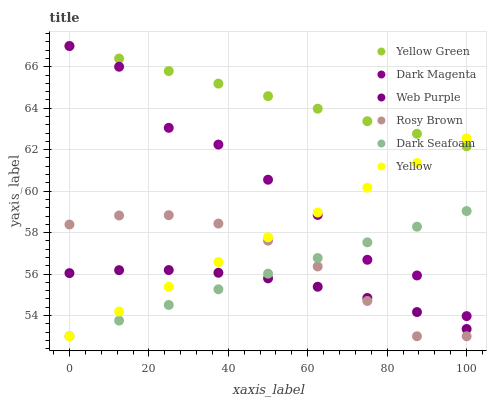Does Web Purple have the minimum area under the curve?
Answer yes or no. Yes. Does Yellow Green have the maximum area under the curve?
Answer yes or no. Yes. Does Rosy Brown have the minimum area under the curve?
Answer yes or no. No. Does Rosy Brown have the maximum area under the curve?
Answer yes or no. No. Is Dark Seafoam the smoothest?
Answer yes or no. Yes. Is Dark Magenta the roughest?
Answer yes or no. Yes. Is Rosy Brown the smoothest?
Answer yes or no. No. Is Rosy Brown the roughest?
Answer yes or no. No. Does Rosy Brown have the lowest value?
Answer yes or no. Yes. Does Web Purple have the lowest value?
Answer yes or no. No. Does Dark Magenta have the highest value?
Answer yes or no. Yes. Does Rosy Brown have the highest value?
Answer yes or no. No. Is Web Purple less than Dark Magenta?
Answer yes or no. Yes. Is Dark Magenta greater than Rosy Brown?
Answer yes or no. Yes. Does Yellow intersect Dark Seafoam?
Answer yes or no. Yes. Is Yellow less than Dark Seafoam?
Answer yes or no. No. Is Yellow greater than Dark Seafoam?
Answer yes or no. No. Does Web Purple intersect Dark Magenta?
Answer yes or no. No. 